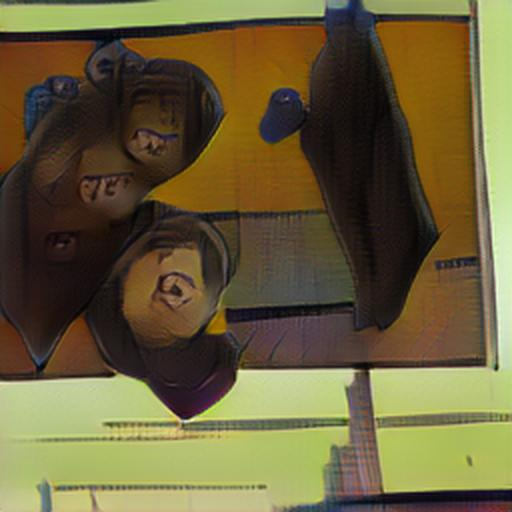Can you analyze the mood or emotion conveyed by the image? Certainly, the image evokes a sense of disorientation and perhaps tension, as the distorted figures often suggest movement or a departure from reality. The mood could be interpreted as unsettling or eerie due to the lack of familiar reference points and the unusual spatial bending. The juxtaposition of warm and cool colors enhances this effect, potentially leading the viewer to experience a mix of curiosity and bewilderment. 